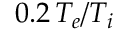Convert formula to latex. <formula><loc_0><loc_0><loc_500><loc_500>0 . 2 \, T _ { e } / T _ { i }</formula> 